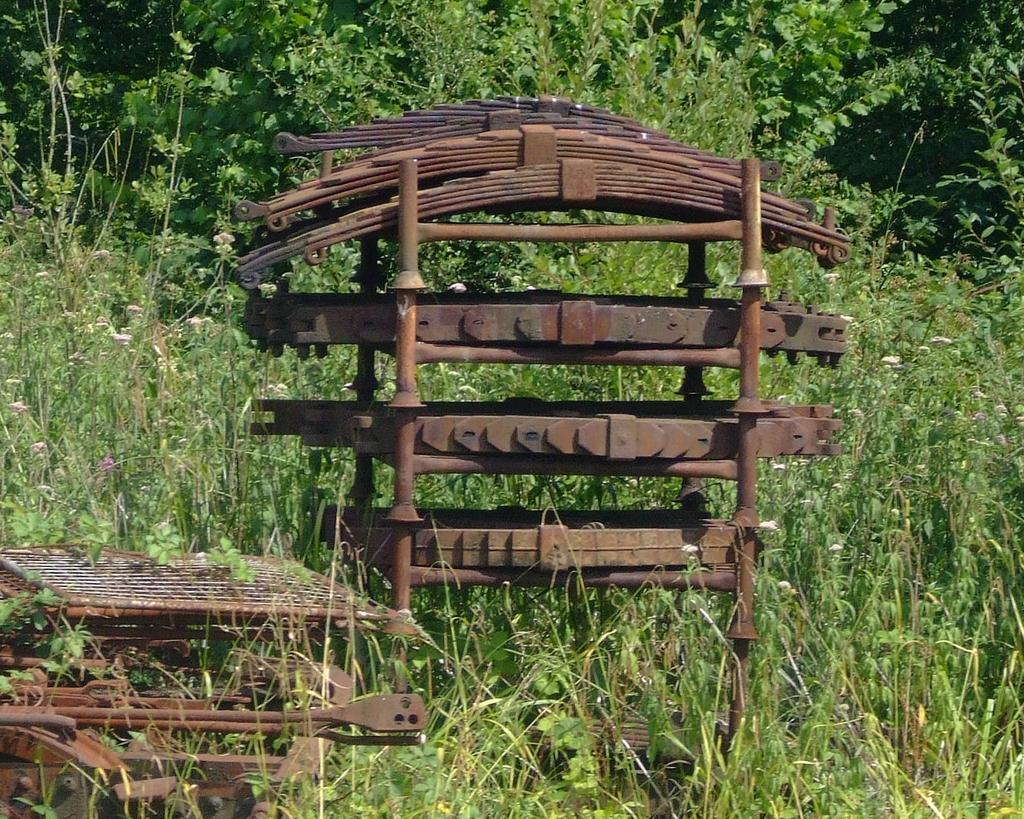What type of objects are made of metal in the image? There are metal objects in the image. Where are the metal objects located? The metal objects are on the land. What type of vegetation can be seen in the image? There are plants and trees in the image. How many cats are sitting on the chair in the image? There are no cats or chairs present in the image. 